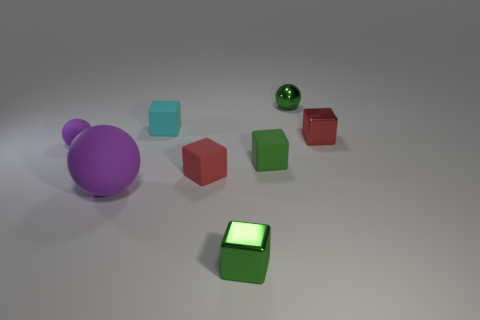How many other rubber objects have the same color as the large rubber thing?
Make the answer very short. 1. There is a metallic sphere; is it the same color as the small metal block that is in front of the large purple sphere?
Keep it short and to the point. Yes. Does the tiny object that is behind the cyan matte thing have the same color as the big ball?
Provide a short and direct response. No. What number of objects are either green shiny balls or red blocks to the left of the green metallic sphere?
Your response must be concise. 2. Do the small red object in front of the small red metallic object and the red metallic thing to the right of the tiny cyan block have the same shape?
Provide a short and direct response. Yes. There is a purple thing that is the same material as the tiny purple ball; what is its shape?
Offer a very short reply. Sphere. What material is the tiny object that is both on the left side of the red matte block and in front of the cyan rubber thing?
Offer a very short reply. Rubber. Is the large matte object the same color as the tiny matte ball?
Provide a short and direct response. Yes. What shape is the tiny shiny thing that is the same color as the small metal sphere?
Ensure brevity in your answer.  Cube. How many other small shiny things are the same shape as the small cyan object?
Give a very brief answer. 2. 